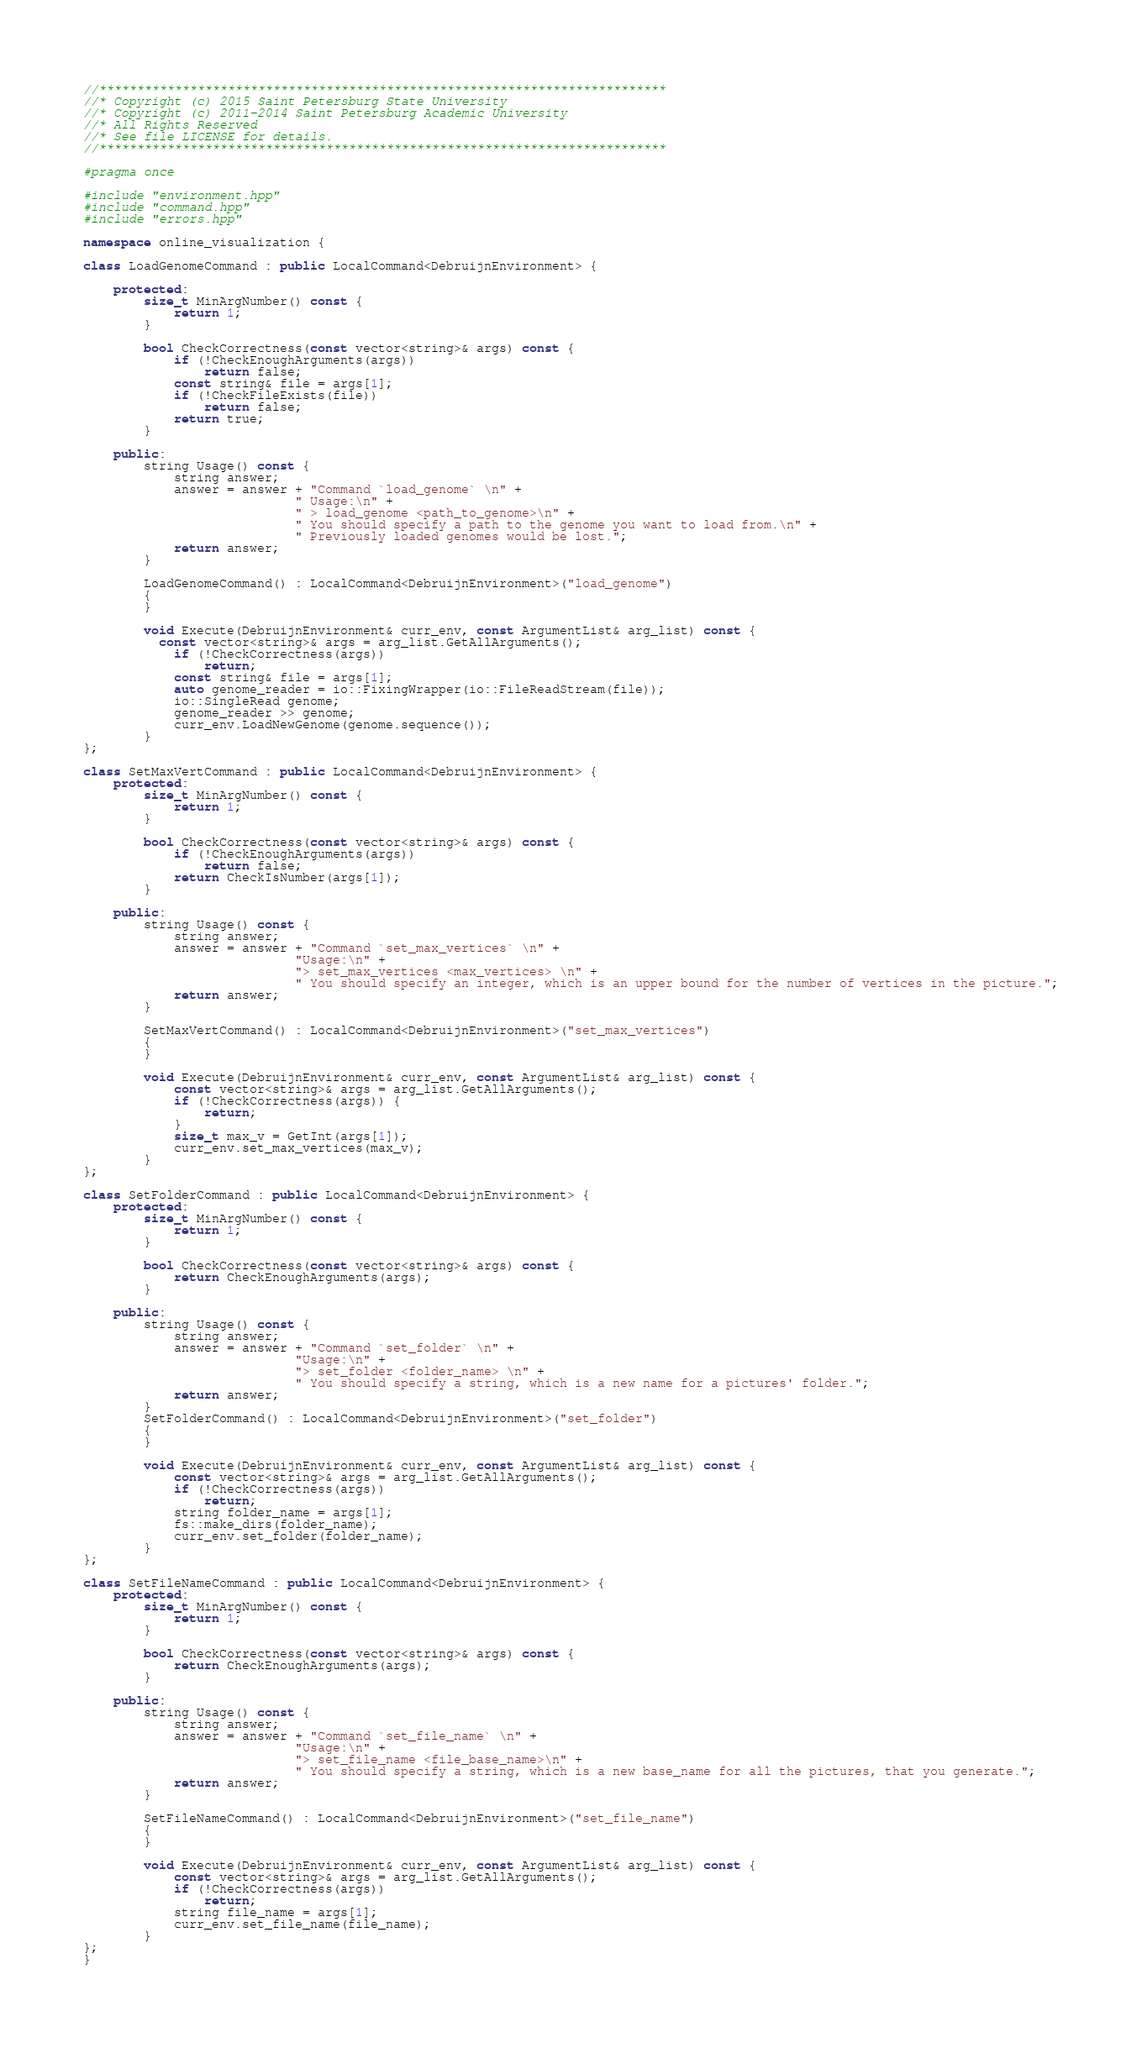<code> <loc_0><loc_0><loc_500><loc_500><_C++_>//***************************************************************************
//* Copyright (c) 2015 Saint Petersburg State University
//* Copyright (c) 2011-2014 Saint Petersburg Academic University
//* All Rights Reserved
//* See file LICENSE for details.
//***************************************************************************

#pragma once

#include "environment.hpp"
#include "command.hpp"
#include "errors.hpp"

namespace online_visualization {

class LoadGenomeCommand : public LocalCommand<DebruijnEnvironment> {

    protected:
        size_t MinArgNumber() const {
            return 1;
        }

        bool CheckCorrectness(const vector<string>& args) const {
            if (!CheckEnoughArguments(args))
                return false;
            const string& file = args[1];
            if (!CheckFileExists(file))
                return false;
            return true;
        }

    public:
        string Usage() const {
            string answer;
            answer = answer + "Command `load_genome` \n" +
                            " Usage:\n" +
                            " > load_genome <path_to_genome>\n" +
                            " You should specify a path to the genome you want to load from.\n" +
                            " Previously loaded genomes would be lost.";
            return answer;
        }

        LoadGenomeCommand() : LocalCommand<DebruijnEnvironment>("load_genome")
        {
        }

        void Execute(DebruijnEnvironment& curr_env, const ArgumentList& arg_list) const {
          const vector<string>& args = arg_list.GetAllArguments();
            if (!CheckCorrectness(args))
                return;
            const string& file = args[1];
            auto genome_reader = io::FixingWrapper(io::FileReadStream(file));
            io::SingleRead genome;
            genome_reader >> genome;
            curr_env.LoadNewGenome(genome.sequence());
        }
};

class SetMaxVertCommand : public LocalCommand<DebruijnEnvironment> {
    protected:
        size_t MinArgNumber() const {
            return 1;
        }

        bool CheckCorrectness(const vector<string>& args) const {
            if (!CheckEnoughArguments(args))
                return false;
            return CheckIsNumber(args[1]);
        }

    public:
        string Usage() const {
            string answer;
            answer = answer + "Command `set_max_vertices` \n" +
                            "Usage:\n" +
                            "> set_max_vertices <max_vertices> \n" +
                            " You should specify an integer, which is an upper bound for the number of vertices in the picture.";
            return answer;
        }

        SetMaxVertCommand() : LocalCommand<DebruijnEnvironment>("set_max_vertices")
        {
        }

        void Execute(DebruijnEnvironment& curr_env, const ArgumentList& arg_list) const {
            const vector<string>& args = arg_list.GetAllArguments();
            if (!CheckCorrectness(args)) {
                return;
            }
            size_t max_v = GetInt(args[1]);
            curr_env.set_max_vertices(max_v);
        }
};

class SetFolderCommand : public LocalCommand<DebruijnEnvironment> {
    protected:
        size_t MinArgNumber() const {
            return 1;
        }

        bool CheckCorrectness(const vector<string>& args) const {
            return CheckEnoughArguments(args);
        }

    public:
        string Usage() const {
            string answer;
            answer = answer + "Command `set_folder` \n" +
                            "Usage:\n" +
                            "> set_folder <folder_name> \n" +
                            " You should specify a string, which is a new name for a pictures' folder.";
            return answer;
        }
        SetFolderCommand() : LocalCommand<DebruijnEnvironment>("set_folder")
        {
        }

        void Execute(DebruijnEnvironment& curr_env, const ArgumentList& arg_list) const {
            const vector<string>& args = arg_list.GetAllArguments();
            if (!CheckCorrectness(args))
                return;
            string folder_name = args[1];
            fs::make_dirs(folder_name);
            curr_env.set_folder(folder_name);
        }
};

class SetFileNameCommand : public LocalCommand<DebruijnEnvironment> {
    protected:
        size_t MinArgNumber() const {
            return 1;
        }

        bool CheckCorrectness(const vector<string>& args) const {
            return CheckEnoughArguments(args);
        }

    public:
        string Usage() const {
            string answer;
            answer = answer + "Command `set_file_name` \n" +
                            "Usage:\n" +
                            "> set_file_name <file_base_name>\n" +
                            " You should specify a string, which is a new base_name for all the pictures, that you generate.";
            return answer;
        }

        SetFileNameCommand() : LocalCommand<DebruijnEnvironment>("set_file_name")
        {
        }

        void Execute(DebruijnEnvironment& curr_env, const ArgumentList& arg_list) const {
            const vector<string>& args = arg_list.GetAllArguments();
            if (!CheckCorrectness(args))
                return;
            string file_name = args[1];
            curr_env.set_file_name(file_name);
        }
};
}

</code> 